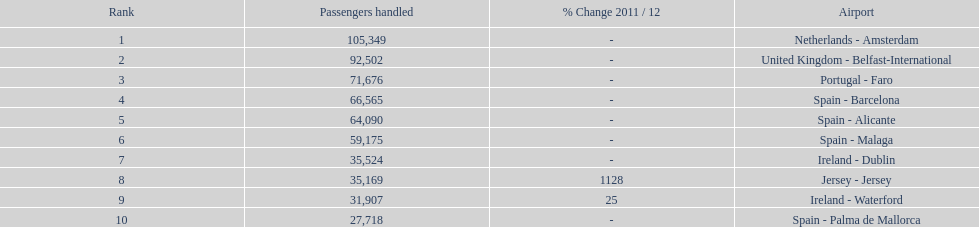How many passengers were handled in an airport in spain? 217,548. Could you parse the entire table? {'header': ['Rank', 'Passengers handled', '% Change 2011 / 12', 'Airport'], 'rows': [['1', '105,349', '-', 'Netherlands - Amsterdam'], ['2', '92,502', '-', 'United Kingdom - Belfast-International'], ['3', '71,676', '-', 'Portugal - Faro'], ['4', '66,565', '-', 'Spain - Barcelona'], ['5', '64,090', '-', 'Spain - Alicante'], ['6', '59,175', '-', 'Spain - Malaga'], ['7', '35,524', '-', 'Ireland - Dublin'], ['8', '35,169', '1128', 'Jersey - Jersey'], ['9', '31,907', '25', 'Ireland - Waterford'], ['10', '27,718', '-', 'Spain - Palma de Mallorca']]} 